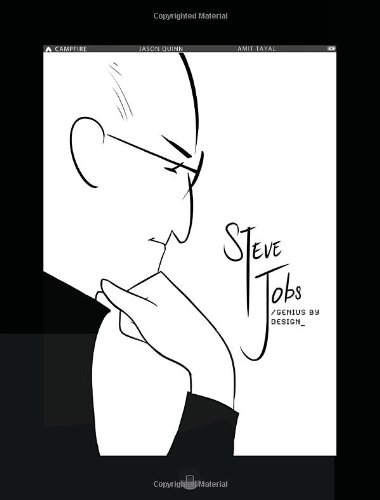Can you tell something about the artist of this book? The artist, Amit Tayal, is well-known for his expressive characters and scenes, which capture complex emotions and pivotal moments effectively. His art adds a dynamic and engaging layer to the storytelling. 